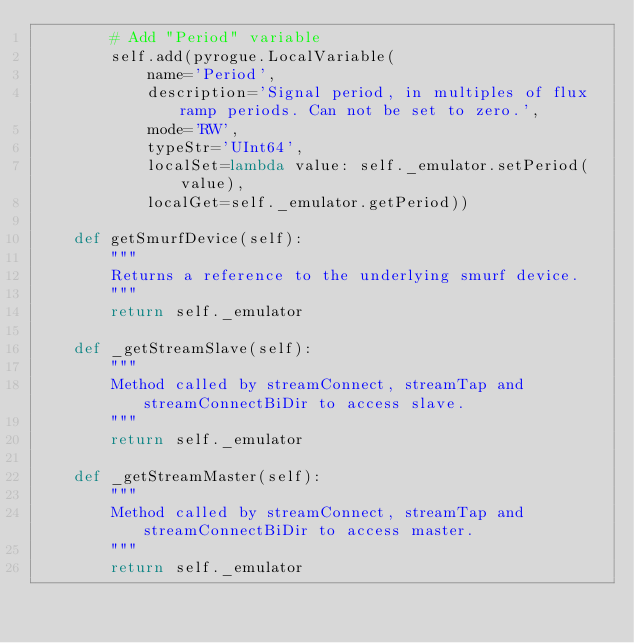Convert code to text. <code><loc_0><loc_0><loc_500><loc_500><_Python_>        # Add "Period" variable
        self.add(pyrogue.LocalVariable(
            name='Period',
            description='Signal period, in multiples of flux ramp periods. Can not be set to zero.',
            mode='RW',
            typeStr='UInt64',
            localSet=lambda value: self._emulator.setPeriod(value),
            localGet=self._emulator.getPeriod))

    def getSmurfDevice(self):
        """
        Returns a reference to the underlying smurf device.
        """
        return self._emulator

    def _getStreamSlave(self):
        """
        Method called by streamConnect, streamTap and streamConnectBiDir to access slave.
        """
        return self._emulator

    def _getStreamMaster(self):
        """
        Method called by streamConnect, streamTap and streamConnectBiDir to access master.
        """
        return self._emulator
</code> 